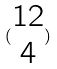<formula> <loc_0><loc_0><loc_500><loc_500>( \begin{matrix} 1 2 \\ 4 \end{matrix} )</formula> 